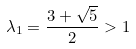Convert formula to latex. <formula><loc_0><loc_0><loc_500><loc_500>\lambda _ { 1 } = \frac { 3 + \sqrt { 5 } } { 2 } > 1</formula> 